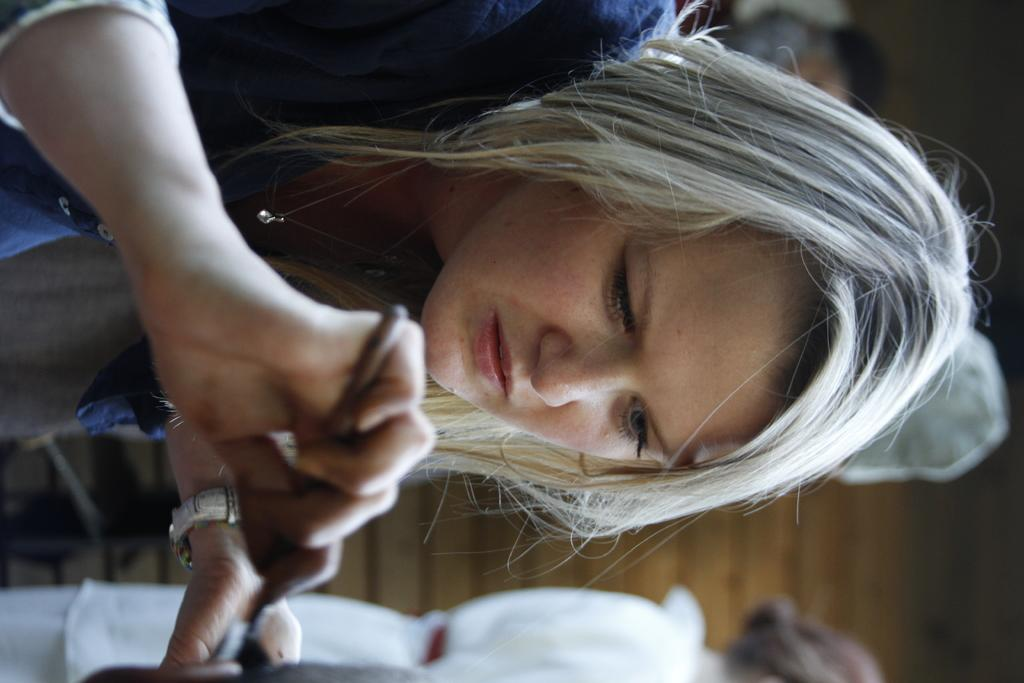What is the woman in the image doing with her hand? The woman is holding a stick in her hand. How many women are present in the image? There are two women in the image. Can you describe the background of the image? The background of the image is blurred. What type of approval is the woman seeking from the robin in the image? There is no robin present in the image, and therefore no interaction with a robin can be observed. How many snakes are visible in the image? There are no snakes present in the image. 